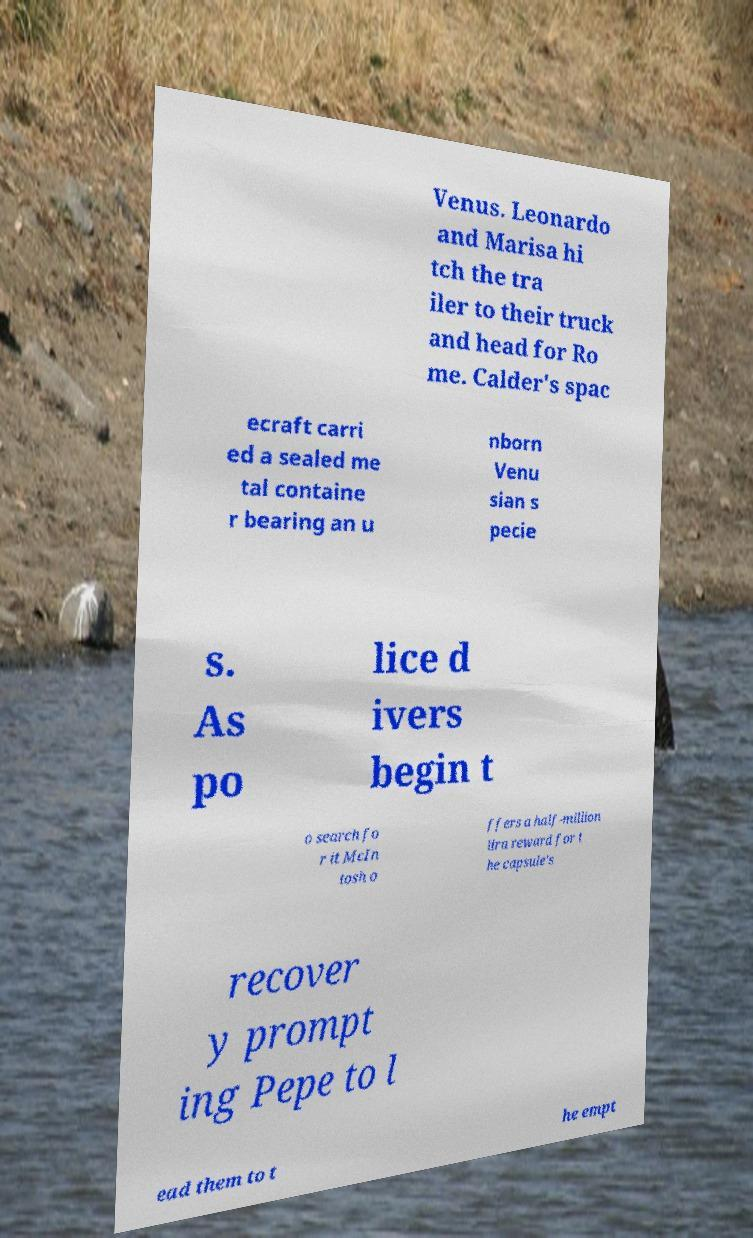Please read and relay the text visible in this image. What does it say? Venus. Leonardo and Marisa hi tch the tra iler to their truck and head for Ro me. Calder's spac ecraft carri ed a sealed me tal containe r bearing an u nborn Venu sian s pecie s. As po lice d ivers begin t o search fo r it McIn tosh o ffers a half-million lira reward for t he capsule's recover y prompt ing Pepe to l ead them to t he empt 